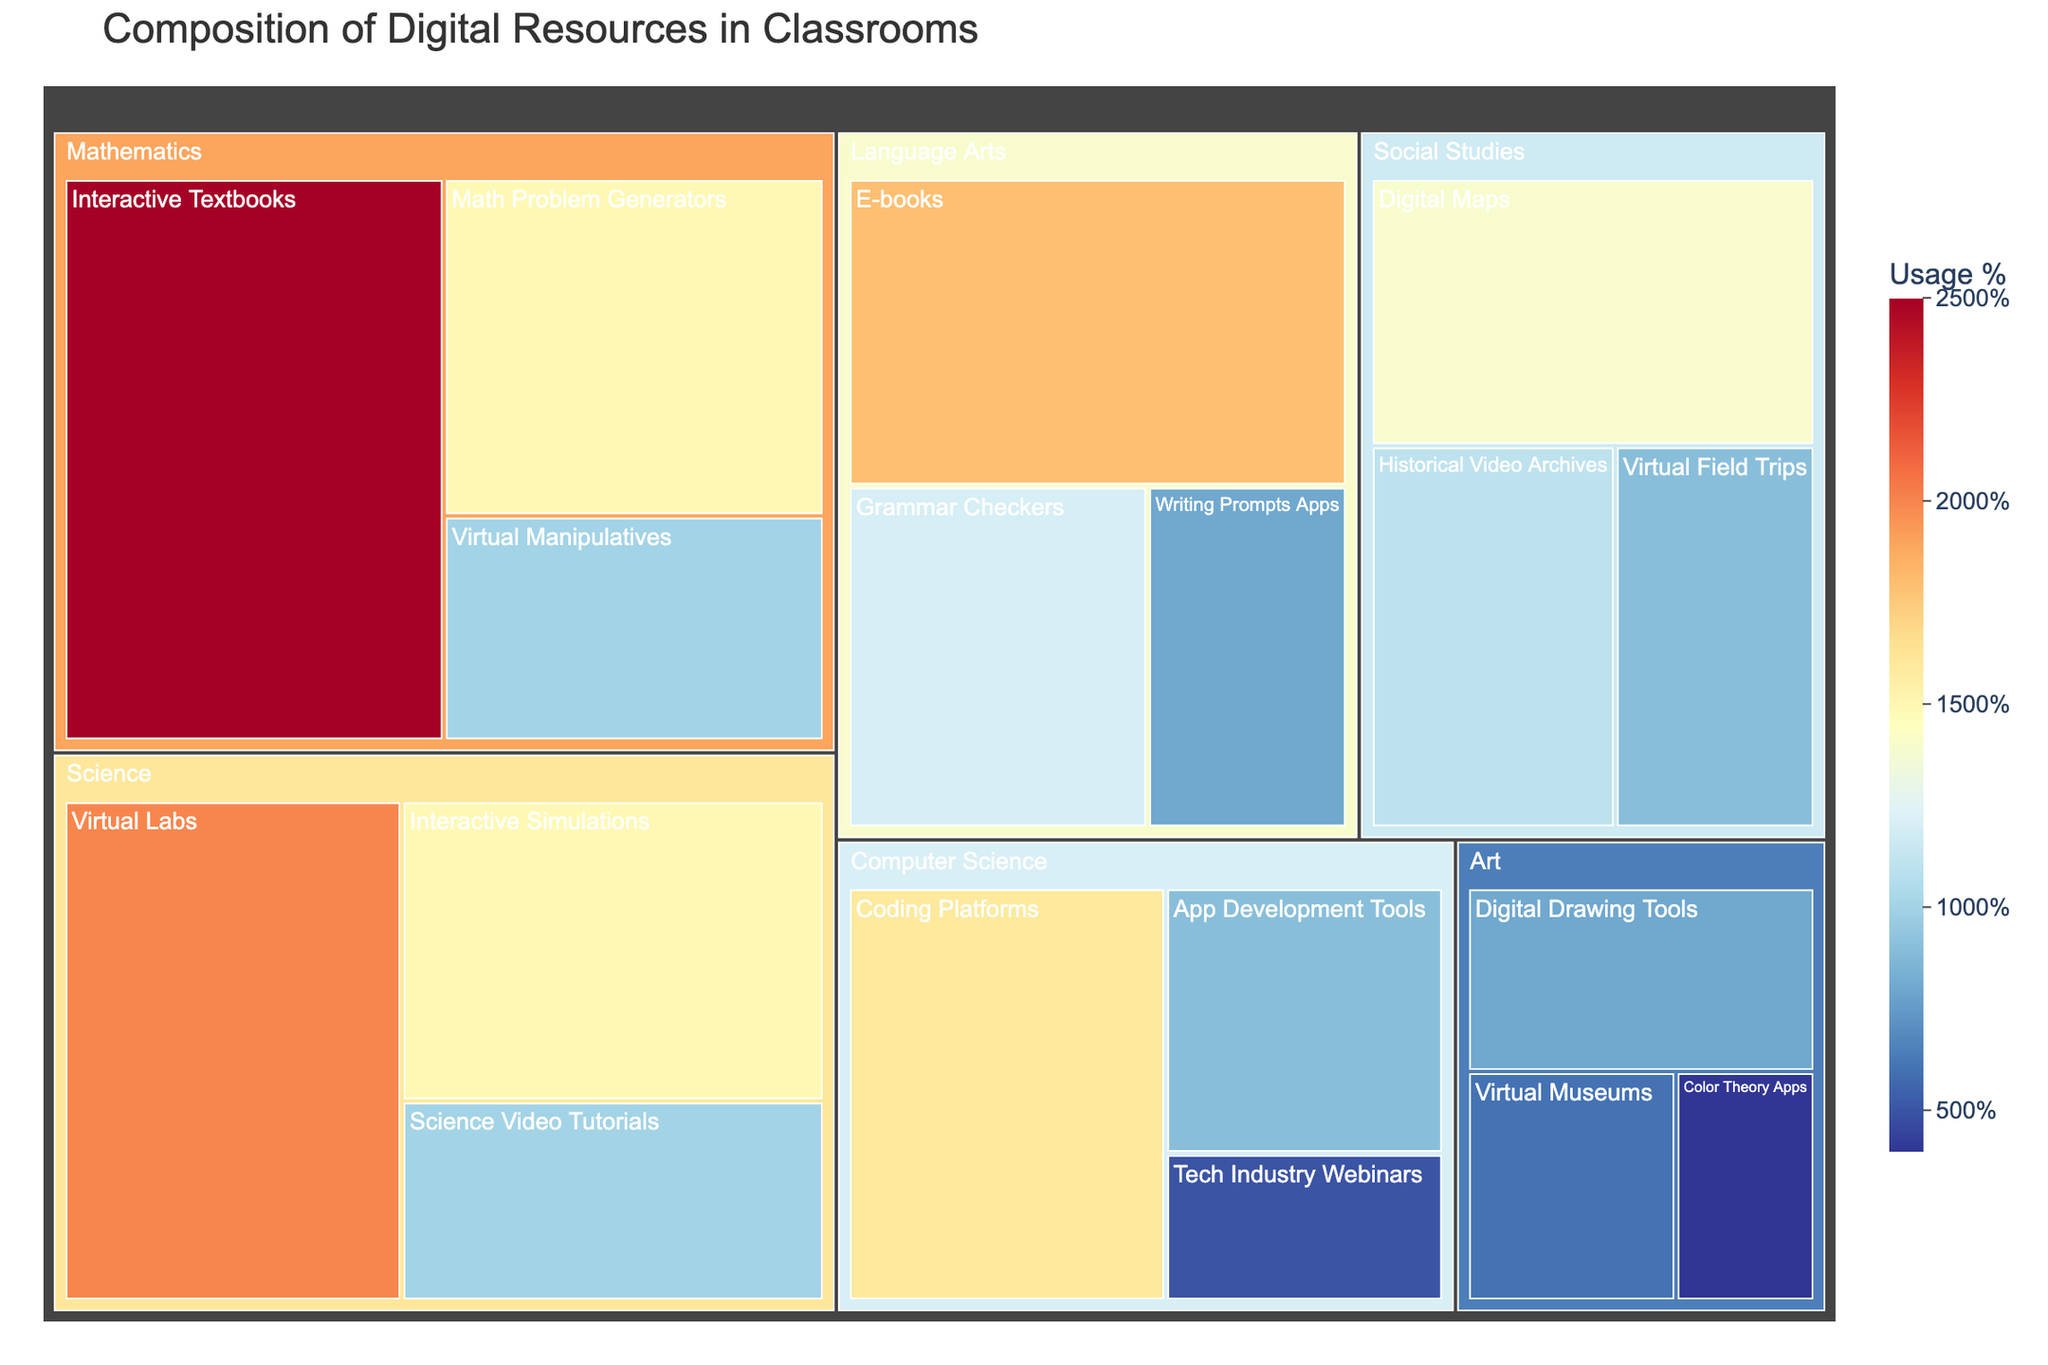How many different subject areas are represented in the treemap? By examining the labeled sections of the treemap, we can count the distinct subject areas that are represented.
Answer: 5 What resource type has the highest usage percentage in Mathematics? Look for the section labeled Mathematics and identify the resource type with the largest area or highest percentage label.
Answer: Interactive Textbooks Which subject uses Virtual Labs, and what is their usage percentage? Locate Virtual Labs in the treemap and observe the subject category it is grouped under along with its labeled usage percentage.
Answer: Science, 20% Compare the use of E-books in Language Arts with Digital Maps in Social Studies. Which one has the higher usage percentage? Find both E-books in Language Arts and Digital Maps in Social Studies in the treemap and compare their respective usage percentages.
Answer: E-books What is the total usage percentage for resource types under the subject of Art? Sum up the usage percentages of Digital Drawing Tools, Virtual Museums, and Color Theory Apps, which are listed under Art.
Answer: 18% Out of the total resources used in the Classroom, what percentage is attributed to Coding Platforms in Computer Science? Find the percentage of Coding Platforms in the Computer Science section and state it.
Answer: 16% Which subject has more diverse types of digital resources, Science or Art? Count the number of resource types listed under Science and Art and compare their counts.
Answer: Science How much more popular are Interactive Simulations compared to App Development Tools in terms of usage percentage? Subtract the usage percentage of App Development Tools from the usage percentage of Interactive Simulations.
Answer: 6% Overall, what is the highest resource usage percentage, and which resource does it correspond to? Observe the treemap to identify the resource type with the largest area or highest percentage label.
Answer: Interactive Textbooks, 25% 